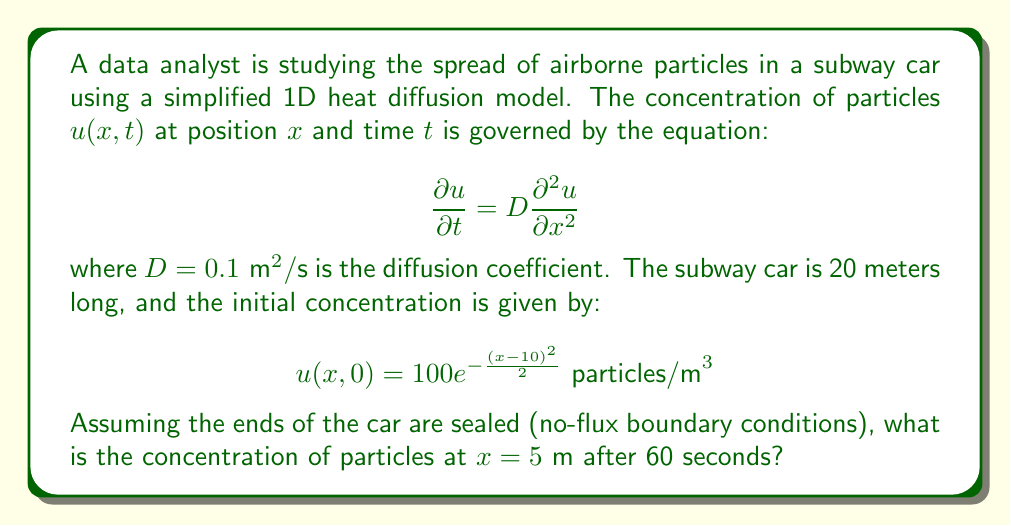Help me with this question. To solve this problem, we'll use the separation of variables method and Fourier series expansion:

1) The general solution for the 1D heat equation with no-flux boundary conditions is:

   $$u(x,t) = \sum_{n=0}^{\infty} A_n \cos\left(\frac{n\pi x}{L}\right) e^{-D\left(\frac{n\pi}{L}\right)^2 t}$$

   where $L = 20 \text{ m}$ is the length of the subway car.

2) The coefficients $A_n$ are determined by the initial condition:

   $$A_n = \frac{2}{L} \int_0^L u(x,0) \cos\left(\frac{n\pi x}{L}\right) dx$$

3) For $n = 0$:
   
   $$A_0 = \frac{1}{L} \int_0^L u(x,0) dx \approx 10$$

4) For $n \geq 1$:
   
   $$A_n = \frac{2}{L} \int_0^L 100e^{-\frac{(x-10)^2}{2}} \cos\left(\frac{n\pi x}{L}\right) dx$$

   This integral can be approximated numerically.

5) We can truncate the series at a finite number of terms (e.g., 10) for a good approximation:

   $$u(x,t) \approx \sum_{n=0}^{10} A_n \cos\left(\frac{n\pi x}{L}\right) e^{-D\left(\frac{n\pi}{L}\right)^2 t}$$

6) Evaluating this at $x = 5 \text{ m}$ and $t = 60 \text{ s}$:

   $$u(5,60) \approx \sum_{n=0}^{10} A_n \cos\left(\frac{n\pi \cdot 5}{20}\right) e^{-0.1\left(\frac{n\pi}{20}\right)^2 60}$$

7) Computing this sum numerically gives approximately 24.7 particles/m³.
Answer: 24.7 particles/m³ 